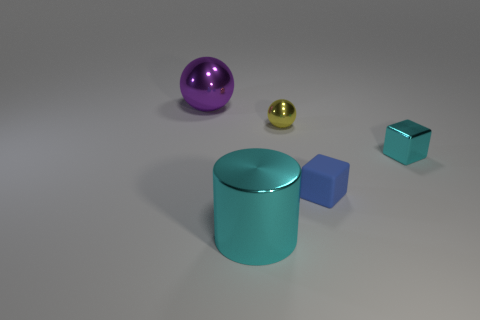There is a thing that is in front of the cyan shiny block and left of the small blue cube; what shape is it?
Your answer should be very brief. Cylinder. What is the color of the shiny ball to the left of the shiny cylinder?
Keep it short and to the point. Purple. What is the size of the metal object that is both in front of the small yellow metal sphere and behind the big cylinder?
Keep it short and to the point. Small. Is the material of the tiny yellow thing the same as the purple object left of the large cyan object?
Offer a terse response. Yes. What number of tiny blue objects have the same shape as the purple object?
Offer a terse response. 0. What material is the big object that is the same color as the small shiny block?
Keep it short and to the point. Metal. How many small matte cubes are there?
Make the answer very short. 1. There is a small yellow thing; is it the same shape as the large object on the left side of the cyan cylinder?
Provide a short and direct response. Yes. How many objects are yellow metal objects or spheres to the right of the purple metallic sphere?
Make the answer very short. 1. There is another object that is the same shape as the small cyan object; what material is it?
Make the answer very short. Rubber. 